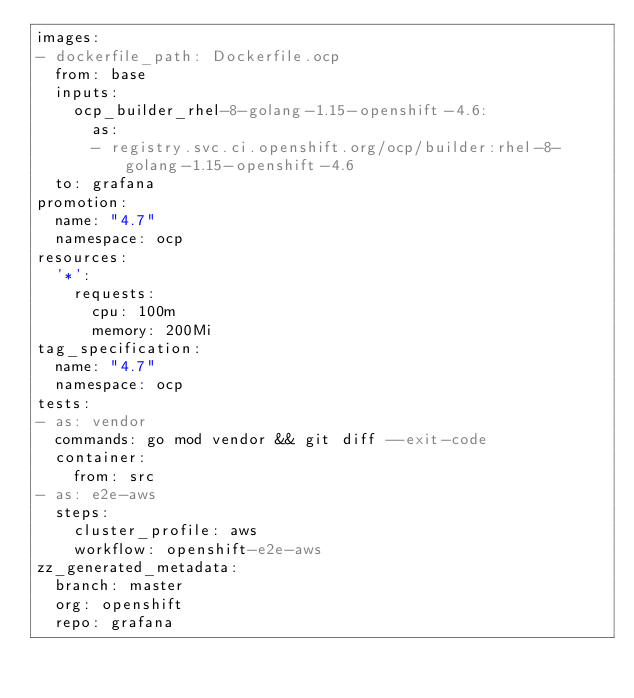Convert code to text. <code><loc_0><loc_0><loc_500><loc_500><_YAML_>images:
- dockerfile_path: Dockerfile.ocp
  from: base
  inputs:
    ocp_builder_rhel-8-golang-1.15-openshift-4.6:
      as:
      - registry.svc.ci.openshift.org/ocp/builder:rhel-8-golang-1.15-openshift-4.6
  to: grafana
promotion:
  name: "4.7"
  namespace: ocp
resources:
  '*':
    requests:
      cpu: 100m
      memory: 200Mi
tag_specification:
  name: "4.7"
  namespace: ocp
tests:
- as: vendor
  commands: go mod vendor && git diff --exit-code
  container:
    from: src
- as: e2e-aws
  steps:
    cluster_profile: aws
    workflow: openshift-e2e-aws
zz_generated_metadata:
  branch: master
  org: openshift
  repo: grafana
</code> 